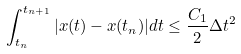<formula> <loc_0><loc_0><loc_500><loc_500>\int _ { t _ { n } } ^ { t _ { n + 1 } } | x ( t ) - x ( t _ { n } ) | d t \leq \frac { C _ { 1 } } { 2 } \Delta t ^ { 2 }</formula> 